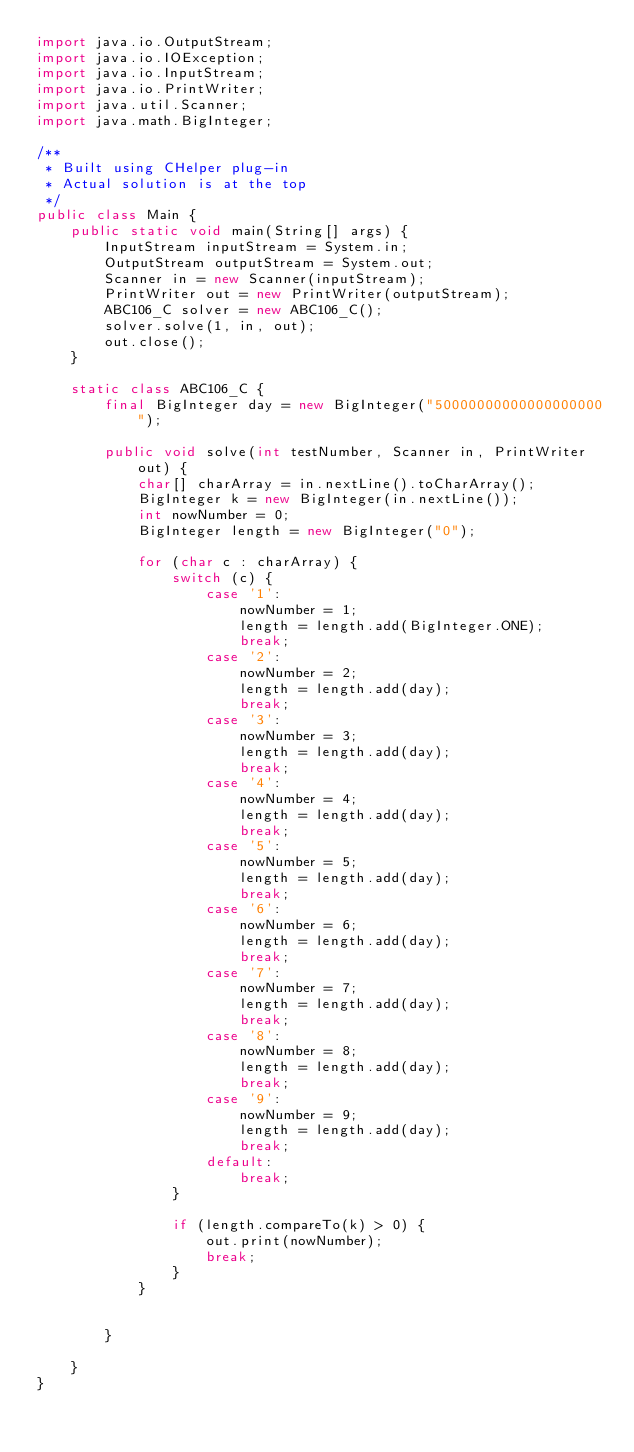<code> <loc_0><loc_0><loc_500><loc_500><_Java_>import java.io.OutputStream;
import java.io.IOException;
import java.io.InputStream;
import java.io.PrintWriter;
import java.util.Scanner;
import java.math.BigInteger;

/**
 * Built using CHelper plug-in
 * Actual solution is at the top
 */
public class Main {
    public static void main(String[] args) {
        InputStream inputStream = System.in;
        OutputStream outputStream = System.out;
        Scanner in = new Scanner(inputStream);
        PrintWriter out = new PrintWriter(outputStream);
        ABC106_C solver = new ABC106_C();
        solver.solve(1, in, out);
        out.close();
    }

    static class ABC106_C {
        final BigInteger day = new BigInteger("50000000000000000000");

        public void solve(int testNumber, Scanner in, PrintWriter out) {
            char[] charArray = in.nextLine().toCharArray();
            BigInteger k = new BigInteger(in.nextLine());
            int nowNumber = 0;
            BigInteger length = new BigInteger("0");

            for (char c : charArray) {
                switch (c) {
                    case '1':
                        nowNumber = 1;
                        length = length.add(BigInteger.ONE);
                        break;
                    case '2':
                        nowNumber = 2;
                        length = length.add(day);
                        break;
                    case '3':
                        nowNumber = 3;
                        length = length.add(day);
                        break;
                    case '4':
                        nowNumber = 4;
                        length = length.add(day);
                        break;
                    case '5':
                        nowNumber = 5;
                        length = length.add(day);
                        break;
                    case '6':
                        nowNumber = 6;
                        length = length.add(day);
                        break;
                    case '7':
                        nowNumber = 7;
                        length = length.add(day);
                        break;
                    case '8':
                        nowNumber = 8;
                        length = length.add(day);
                        break;
                    case '9':
                        nowNumber = 9;
                        length = length.add(day);
                        break;
                    default:
                        break;
                }

                if (length.compareTo(k) > 0) {
                    out.print(nowNumber);
                    break;
                }
            }


        }

    }
}

</code> 